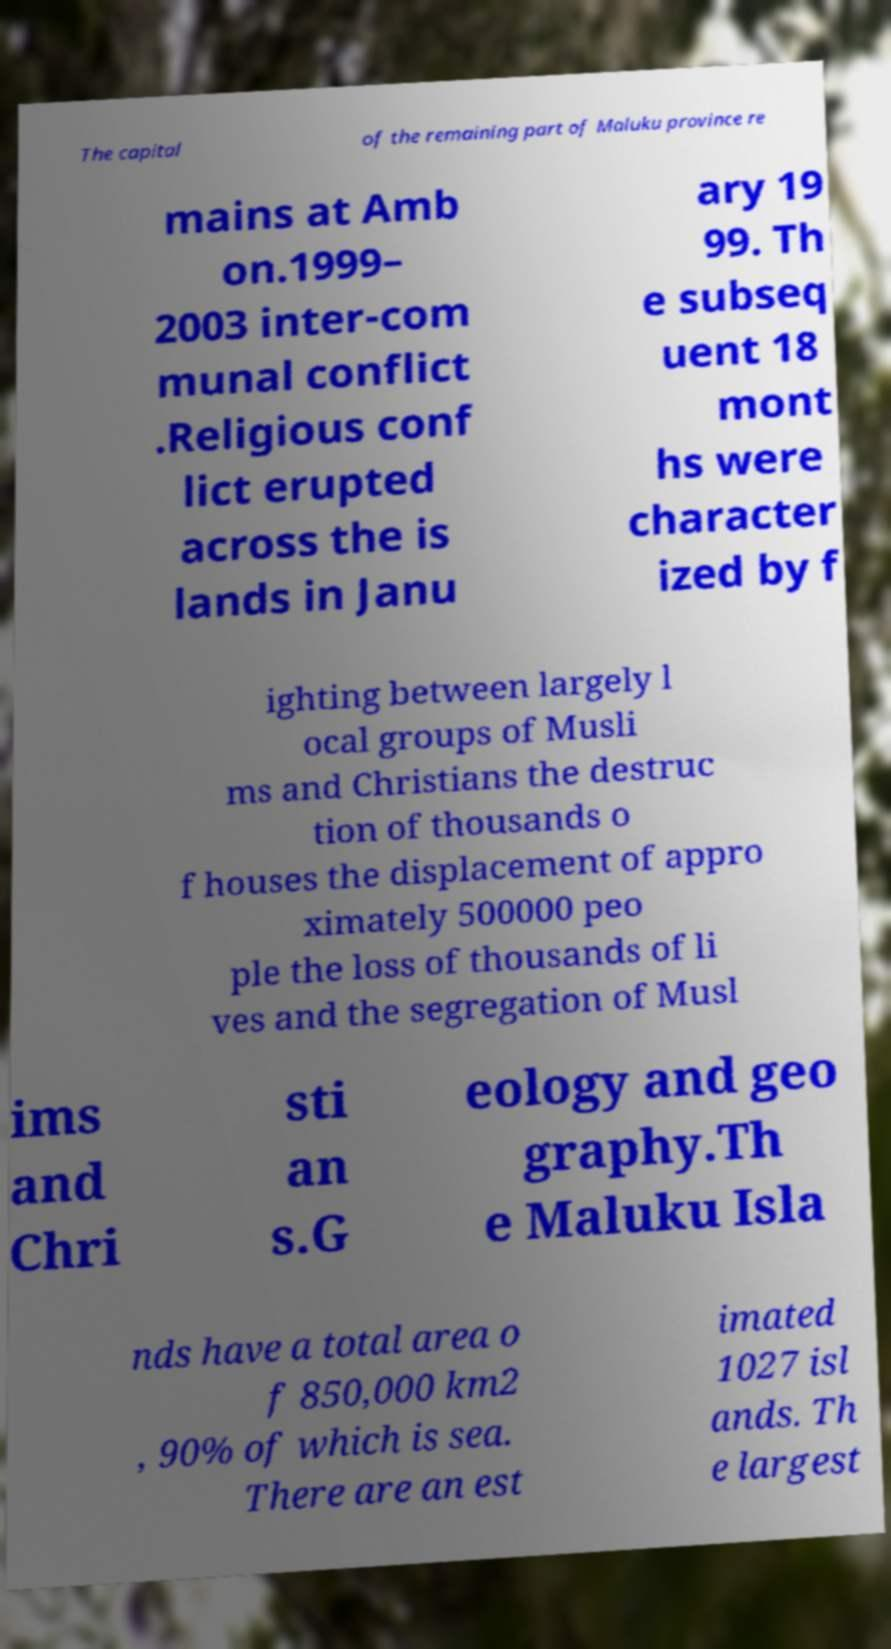Can you accurately transcribe the text from the provided image for me? The capital of the remaining part of Maluku province re mains at Amb on.1999– 2003 inter-com munal conflict .Religious conf lict erupted across the is lands in Janu ary 19 99. Th e subseq uent 18 mont hs were character ized by f ighting between largely l ocal groups of Musli ms and Christians the destruc tion of thousands o f houses the displacement of appro ximately 500000 peo ple the loss of thousands of li ves and the segregation of Musl ims and Chri sti an s.G eology and geo graphy.Th e Maluku Isla nds have a total area o f 850,000 km2 , 90% of which is sea. There are an est imated 1027 isl ands. Th e largest 